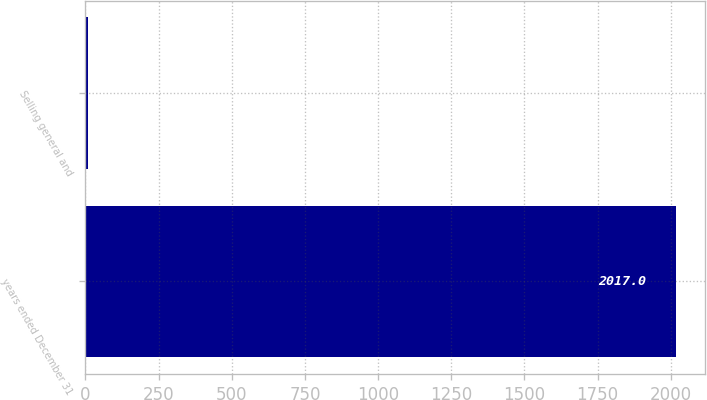<chart> <loc_0><loc_0><loc_500><loc_500><bar_chart><fcel>years ended December 31<fcel>Selling general and<nl><fcel>2017<fcel>7<nl></chart> 